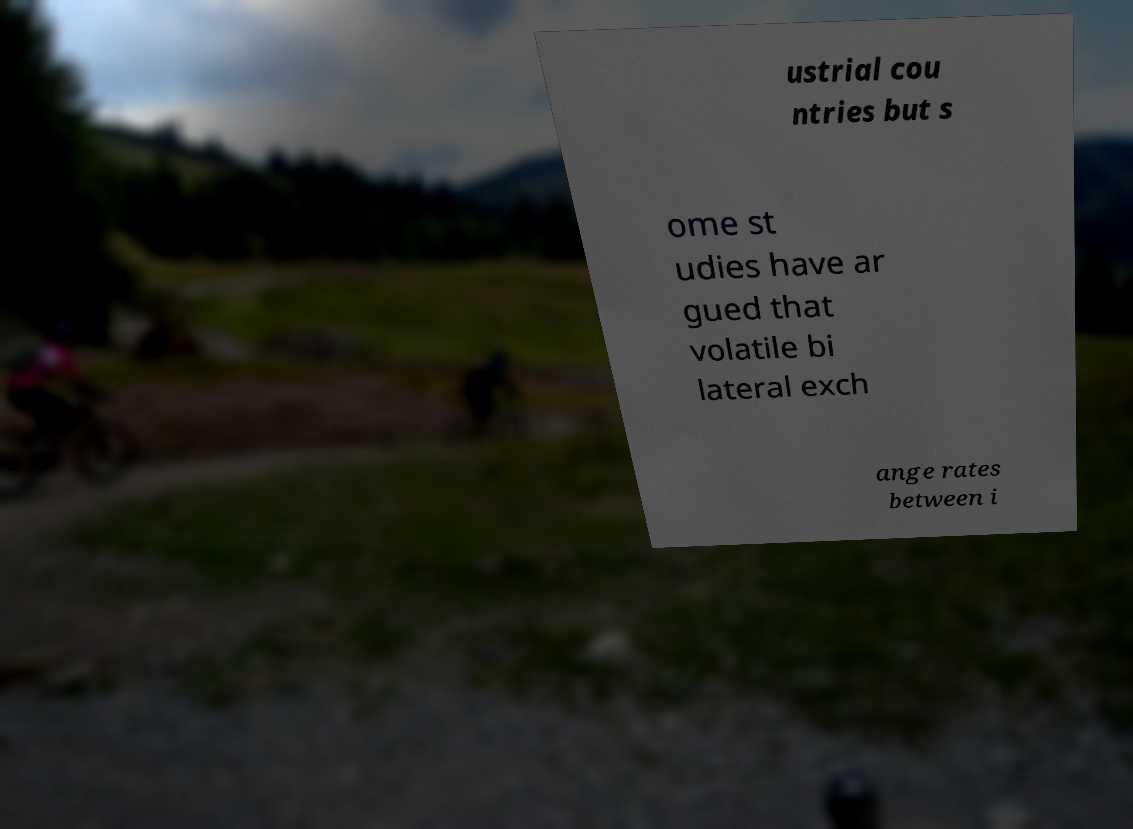Could you assist in decoding the text presented in this image and type it out clearly? ustrial cou ntries but s ome st udies have ar gued that volatile bi lateral exch ange rates between i 